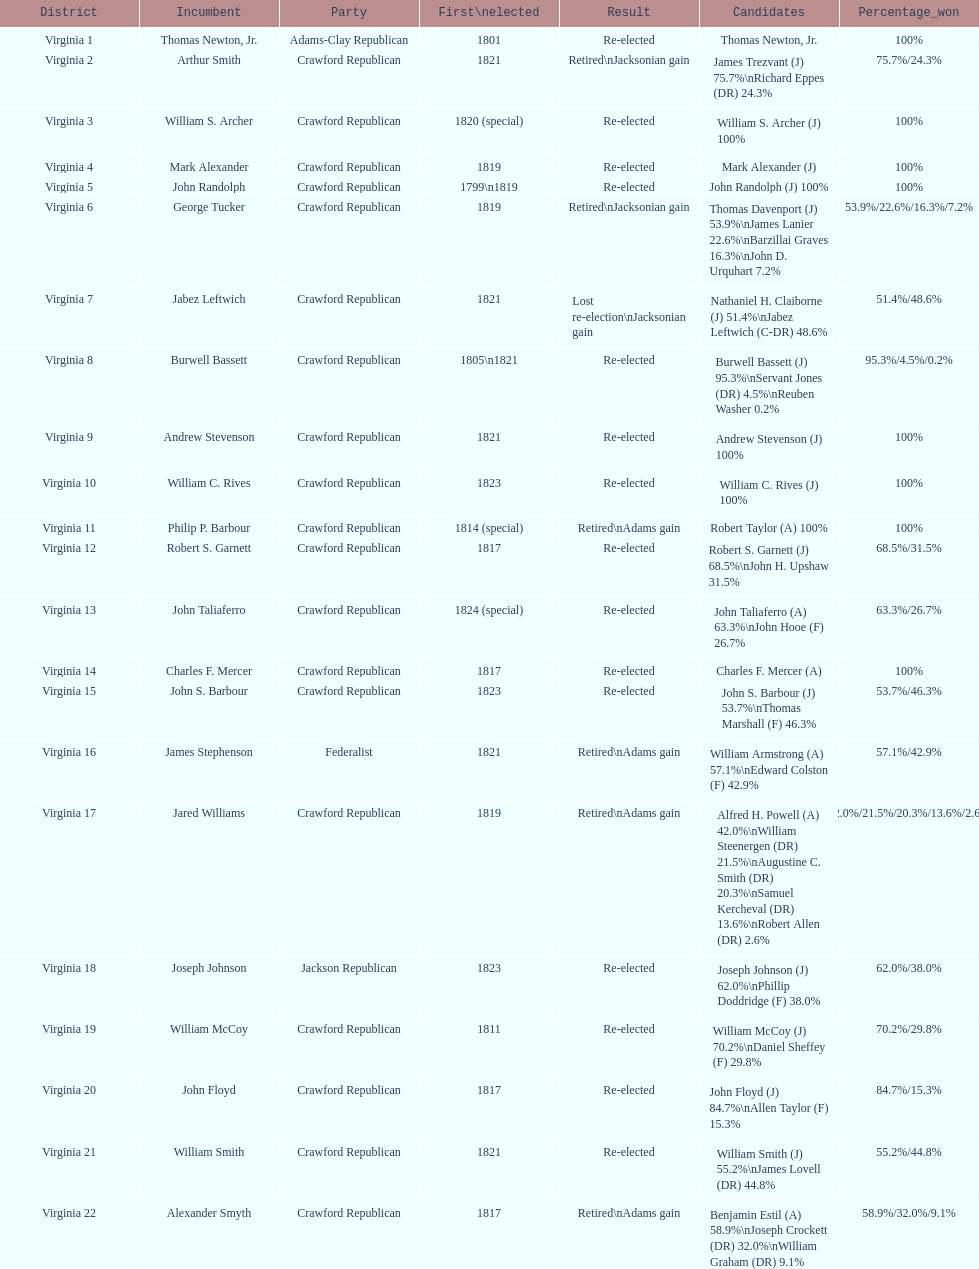Which jacksonian candidates got at least 76% of the vote in their races? Arthur Smith. 